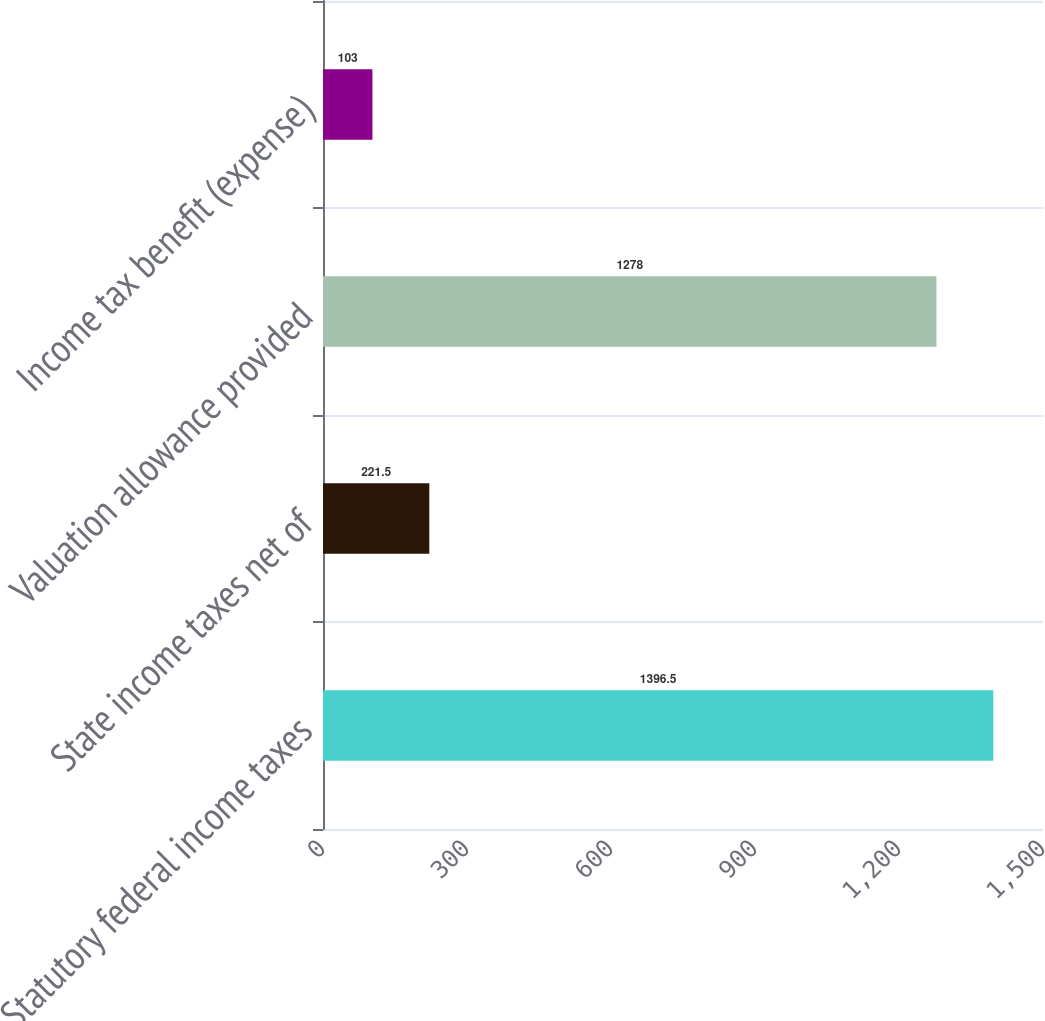Convert chart. <chart><loc_0><loc_0><loc_500><loc_500><bar_chart><fcel>Statutory federal income taxes<fcel>State income taxes net of<fcel>Valuation allowance provided<fcel>Income tax benefit (expense)<nl><fcel>1396.5<fcel>221.5<fcel>1278<fcel>103<nl></chart> 